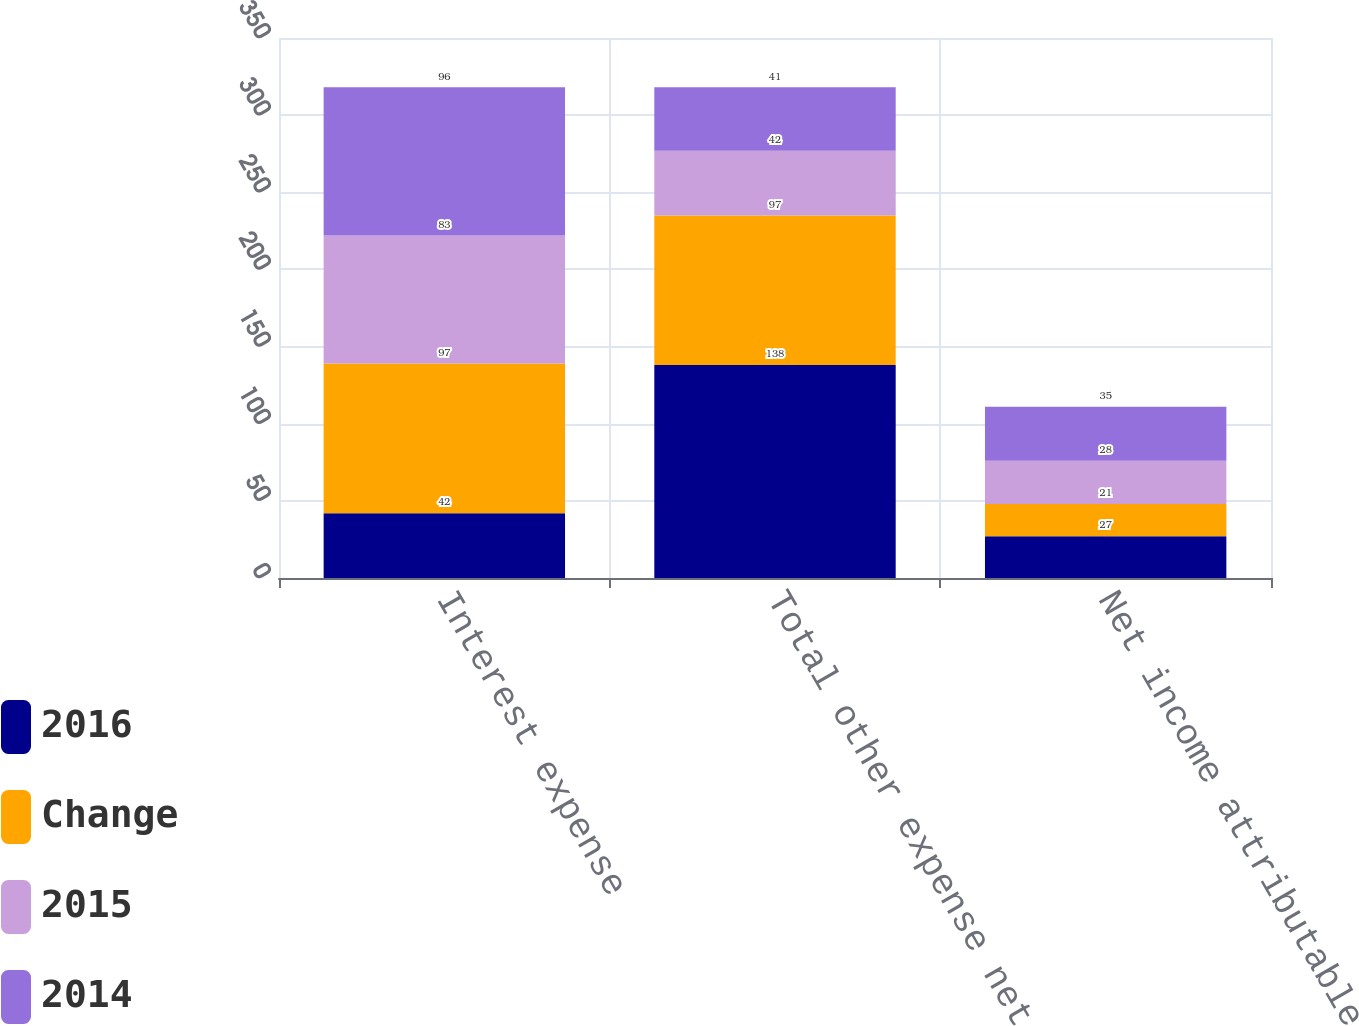Convert chart to OTSL. <chart><loc_0><loc_0><loc_500><loc_500><stacked_bar_chart><ecel><fcel>Interest expense<fcel>Total other expense net<fcel>Net income attributable to<nl><fcel>2016<fcel>42<fcel>138<fcel>27<nl><fcel>Change<fcel>97<fcel>97<fcel>21<nl><fcel>2015<fcel>83<fcel>42<fcel>28<nl><fcel>2014<fcel>96<fcel>41<fcel>35<nl></chart> 